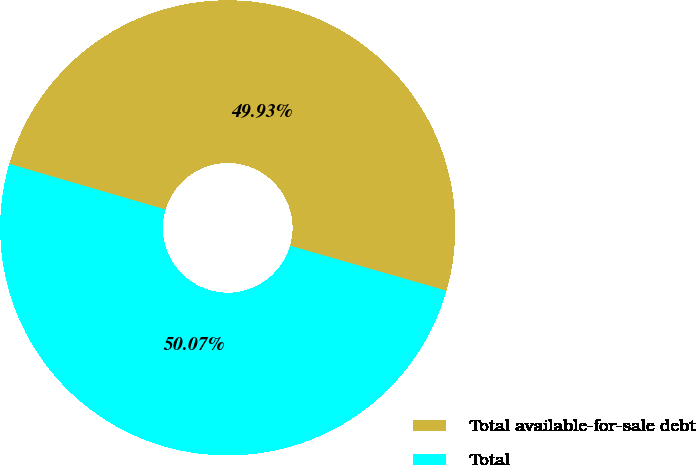Convert chart to OTSL. <chart><loc_0><loc_0><loc_500><loc_500><pie_chart><fcel>Total available-for-sale debt<fcel>Total<nl><fcel>49.93%<fcel>50.07%<nl></chart> 